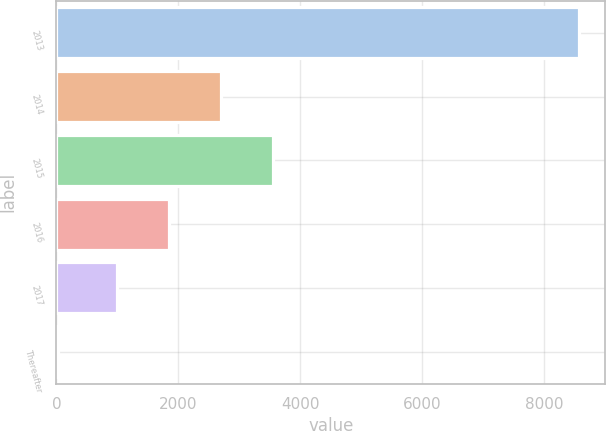<chart> <loc_0><loc_0><loc_500><loc_500><bar_chart><fcel>2013<fcel>2014<fcel>2015<fcel>2016<fcel>2017<fcel>Thereafter<nl><fcel>8581<fcel>2700.8<fcel>3556.7<fcel>1844.9<fcel>989<fcel>22<nl></chart> 